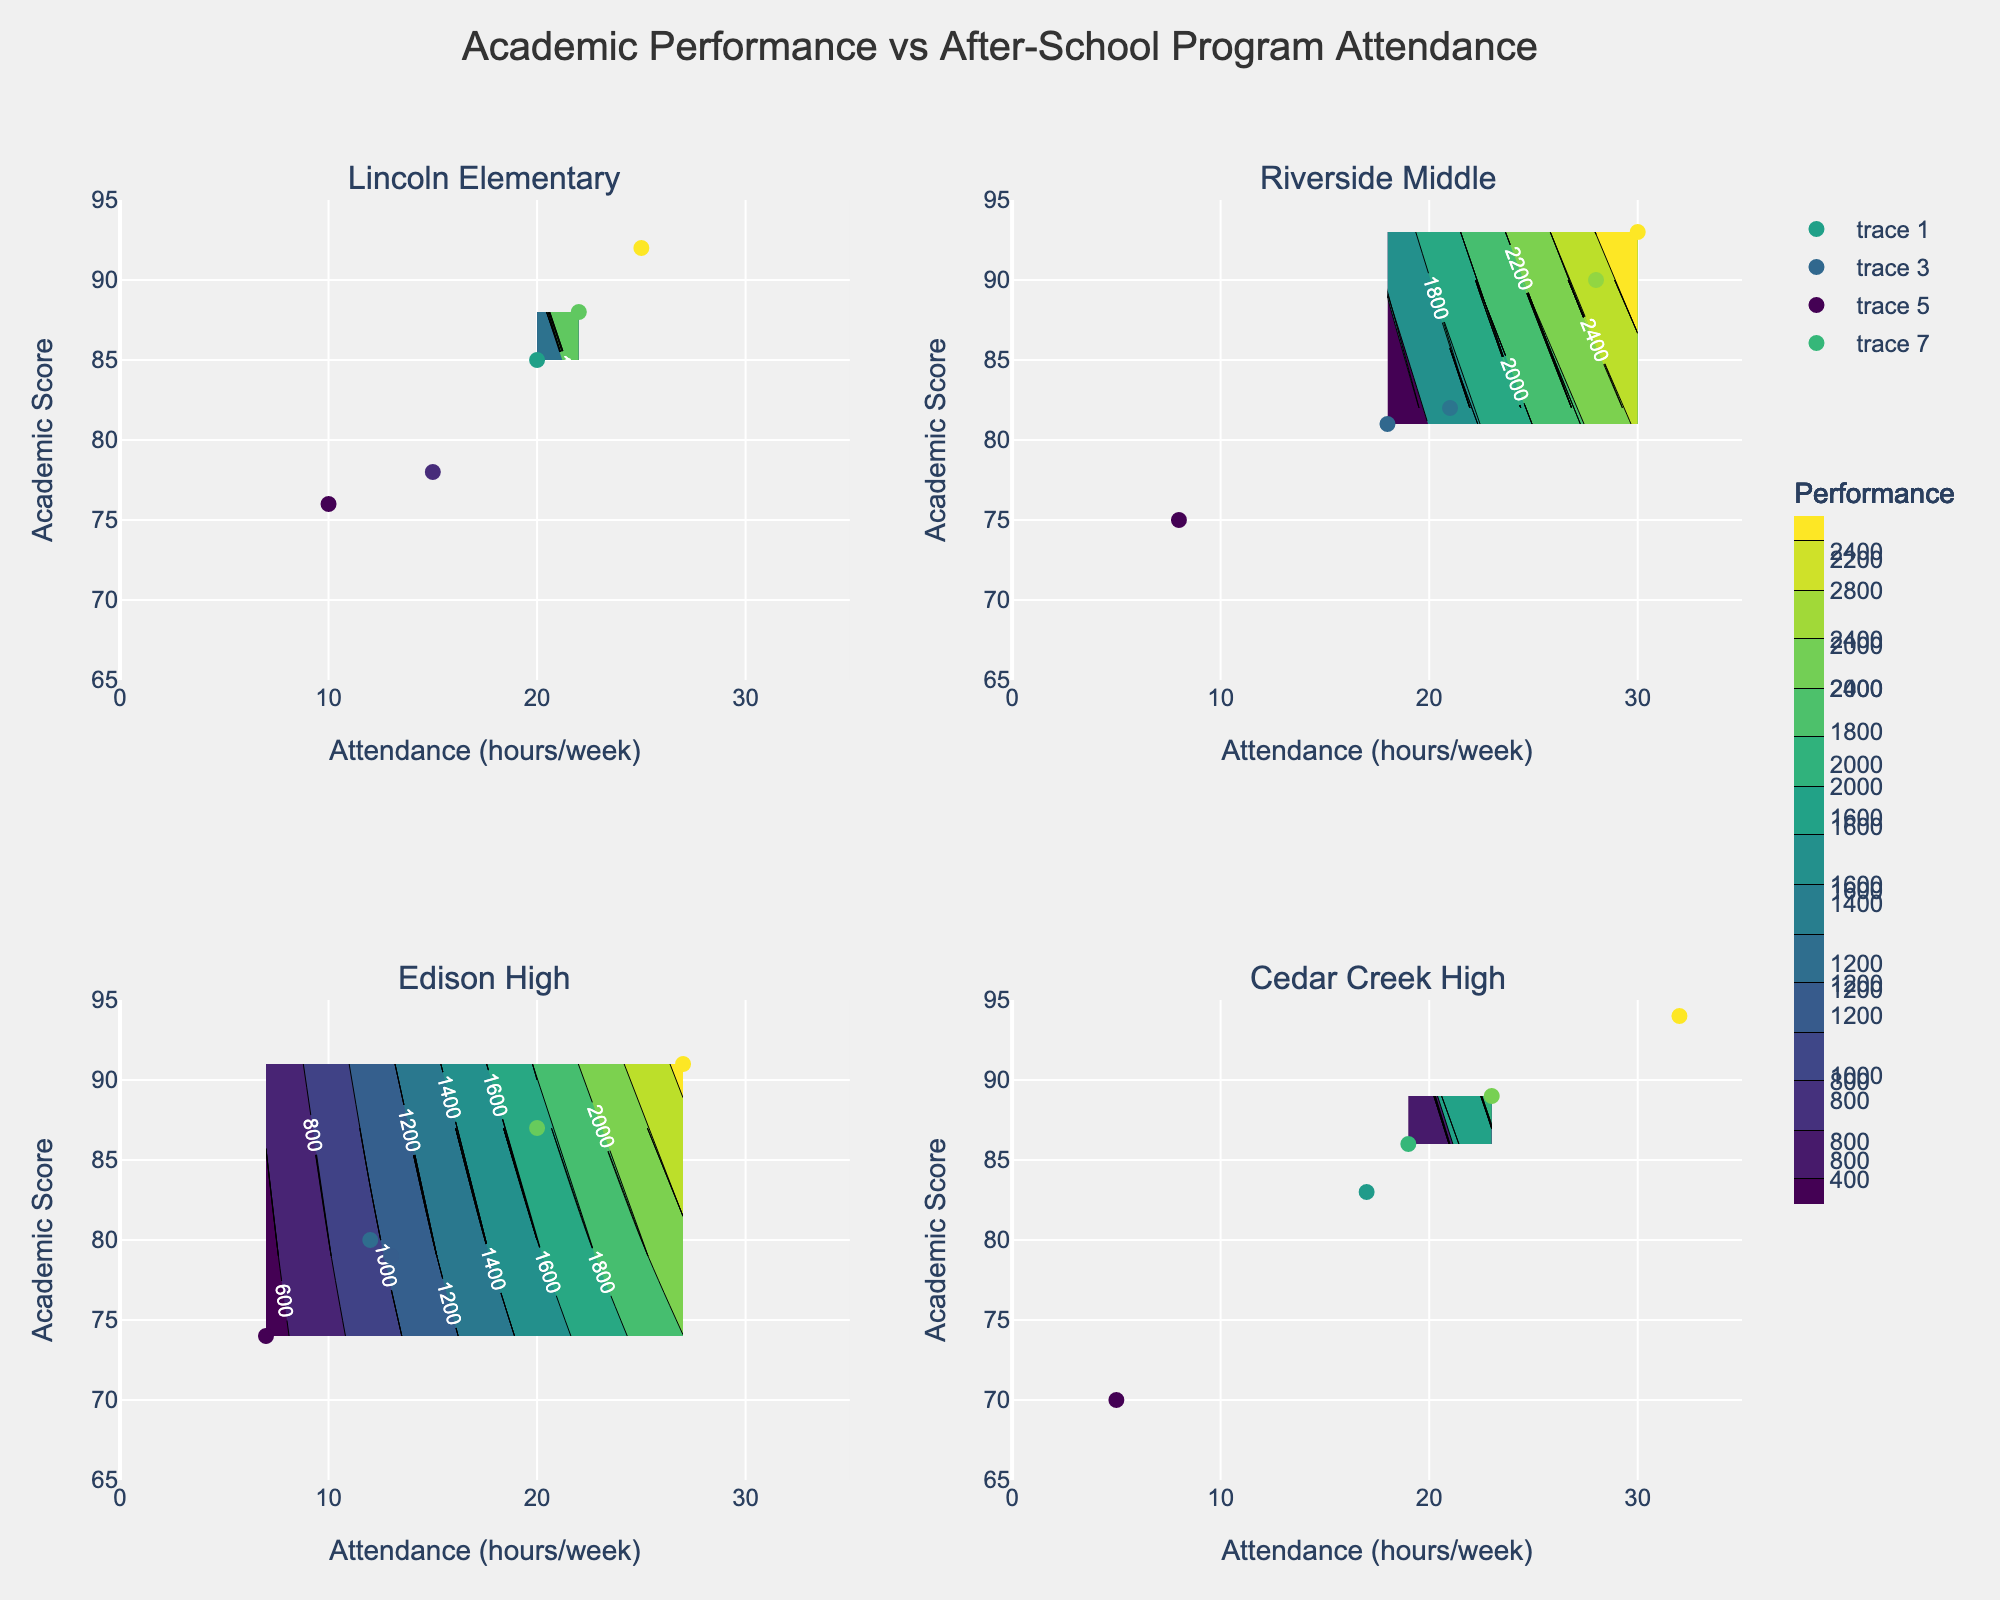What's the title of the figure? The title is usually displayed prominently at the top center of the figure. In this case, it is specified within the code: 'Academic Performance vs After-School Program Attendance'.
Answer: Academic Performance vs After-School Program Attendance How many subplots are there in the figure? A subplot is a single plot within a larger figure composed of multiple plots. The code defines a 2x2 grid, resulting in four subplots.
Answer: Four What is the range of academic performance scores displayed on the y-axis? The range for the academic performance scores on the y-axis is set in the code between 65 and 95. This can be seen by inspecting the y-axis of any of the subplots.
Answer: 65 to 95 Which school has students with the highest attendance in after-school programs? By examining the contour plots and their hover information, we can identify that 'Cedar Creek High' has a student with the highest attendance of 32 hours per week.
Answer: Cedar Creek High What is the general trend between attendance in after-school programs and academic performance scores? Observing the general direction and patterns in the contour plots, a positive trend is visible where higher attendance often aligns with higher academic performance scores.
Answer: Positive trend Which subplot shows the highest concentration of students with scores above 90? By analyzing each subplot, the one for 'Cedar Creek High' displays the highest density of data points and contours in the region with scores above 90.
Answer: Cedar Creek High Which school appears to have the least variability in academic performance scores? From the contour density and spread in subplots, 'Lincoln Elementary' shows less spread in performance scores, indicating lower variability.
Answer: Lincoln Elementary Which school has the widest range of attendance in after-school programs? The subplot for 'Cedar Creek High' indicates a spread of attendance from 5 to 32 hours per week, showing the widest range among the schools.
Answer: Cedar Creek High For which school is the lowest academic performance score recorded? Checking the lowest points in each contour subplot, 'Cedar Creek High' records the lowest academic performance score of 70.
Answer: Cedar Creek High 